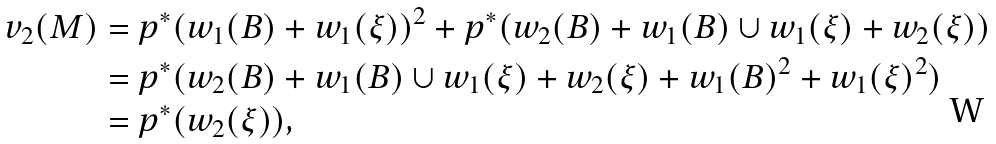<formula> <loc_0><loc_0><loc_500><loc_500>v _ { 2 } ( M ) & = p ^ { * } ( w _ { 1 } ( B ) + w _ { 1 } ( \xi ) ) ^ { 2 } + p ^ { * } ( w _ { 2 } ( B ) + w _ { 1 } ( B ) \cup w _ { 1 } ( \xi ) + w _ { 2 } ( \xi ) ) \\ & = p ^ { * } ( w _ { 2 } ( B ) + w _ { 1 } ( B ) \cup w _ { 1 } ( \xi ) + w _ { 2 } ( \xi ) + w _ { 1 } ( B ) ^ { 2 } + w _ { 1 } ( \xi ) ^ { 2 } ) \\ & = p ^ { * } ( w _ { 2 } ( \xi ) ) , \\</formula> 